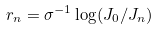Convert formula to latex. <formula><loc_0><loc_0><loc_500><loc_500>r _ { n } = \sigma ^ { - 1 } \log ( J _ { 0 } / J _ { n } )</formula> 